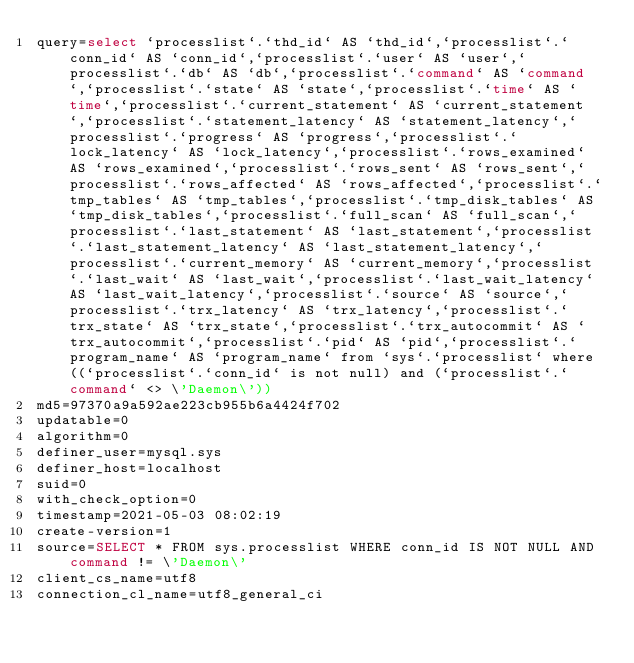Convert code to text. <code><loc_0><loc_0><loc_500><loc_500><_VisualBasic_>query=select `processlist`.`thd_id` AS `thd_id`,`processlist`.`conn_id` AS `conn_id`,`processlist`.`user` AS `user`,`processlist`.`db` AS `db`,`processlist`.`command` AS `command`,`processlist`.`state` AS `state`,`processlist`.`time` AS `time`,`processlist`.`current_statement` AS `current_statement`,`processlist`.`statement_latency` AS `statement_latency`,`processlist`.`progress` AS `progress`,`processlist`.`lock_latency` AS `lock_latency`,`processlist`.`rows_examined` AS `rows_examined`,`processlist`.`rows_sent` AS `rows_sent`,`processlist`.`rows_affected` AS `rows_affected`,`processlist`.`tmp_tables` AS `tmp_tables`,`processlist`.`tmp_disk_tables` AS `tmp_disk_tables`,`processlist`.`full_scan` AS `full_scan`,`processlist`.`last_statement` AS `last_statement`,`processlist`.`last_statement_latency` AS `last_statement_latency`,`processlist`.`current_memory` AS `current_memory`,`processlist`.`last_wait` AS `last_wait`,`processlist`.`last_wait_latency` AS `last_wait_latency`,`processlist`.`source` AS `source`,`processlist`.`trx_latency` AS `trx_latency`,`processlist`.`trx_state` AS `trx_state`,`processlist`.`trx_autocommit` AS `trx_autocommit`,`processlist`.`pid` AS `pid`,`processlist`.`program_name` AS `program_name` from `sys`.`processlist` where ((`processlist`.`conn_id` is not null) and (`processlist`.`command` <> \'Daemon\'))
md5=97370a9a592ae223cb955b6a4424f702
updatable=0
algorithm=0
definer_user=mysql.sys
definer_host=localhost
suid=0
with_check_option=0
timestamp=2021-05-03 08:02:19
create-version=1
source=SELECT * FROM sys.processlist WHERE conn_id IS NOT NULL AND command != \'Daemon\'
client_cs_name=utf8
connection_cl_name=utf8_general_ci</code> 